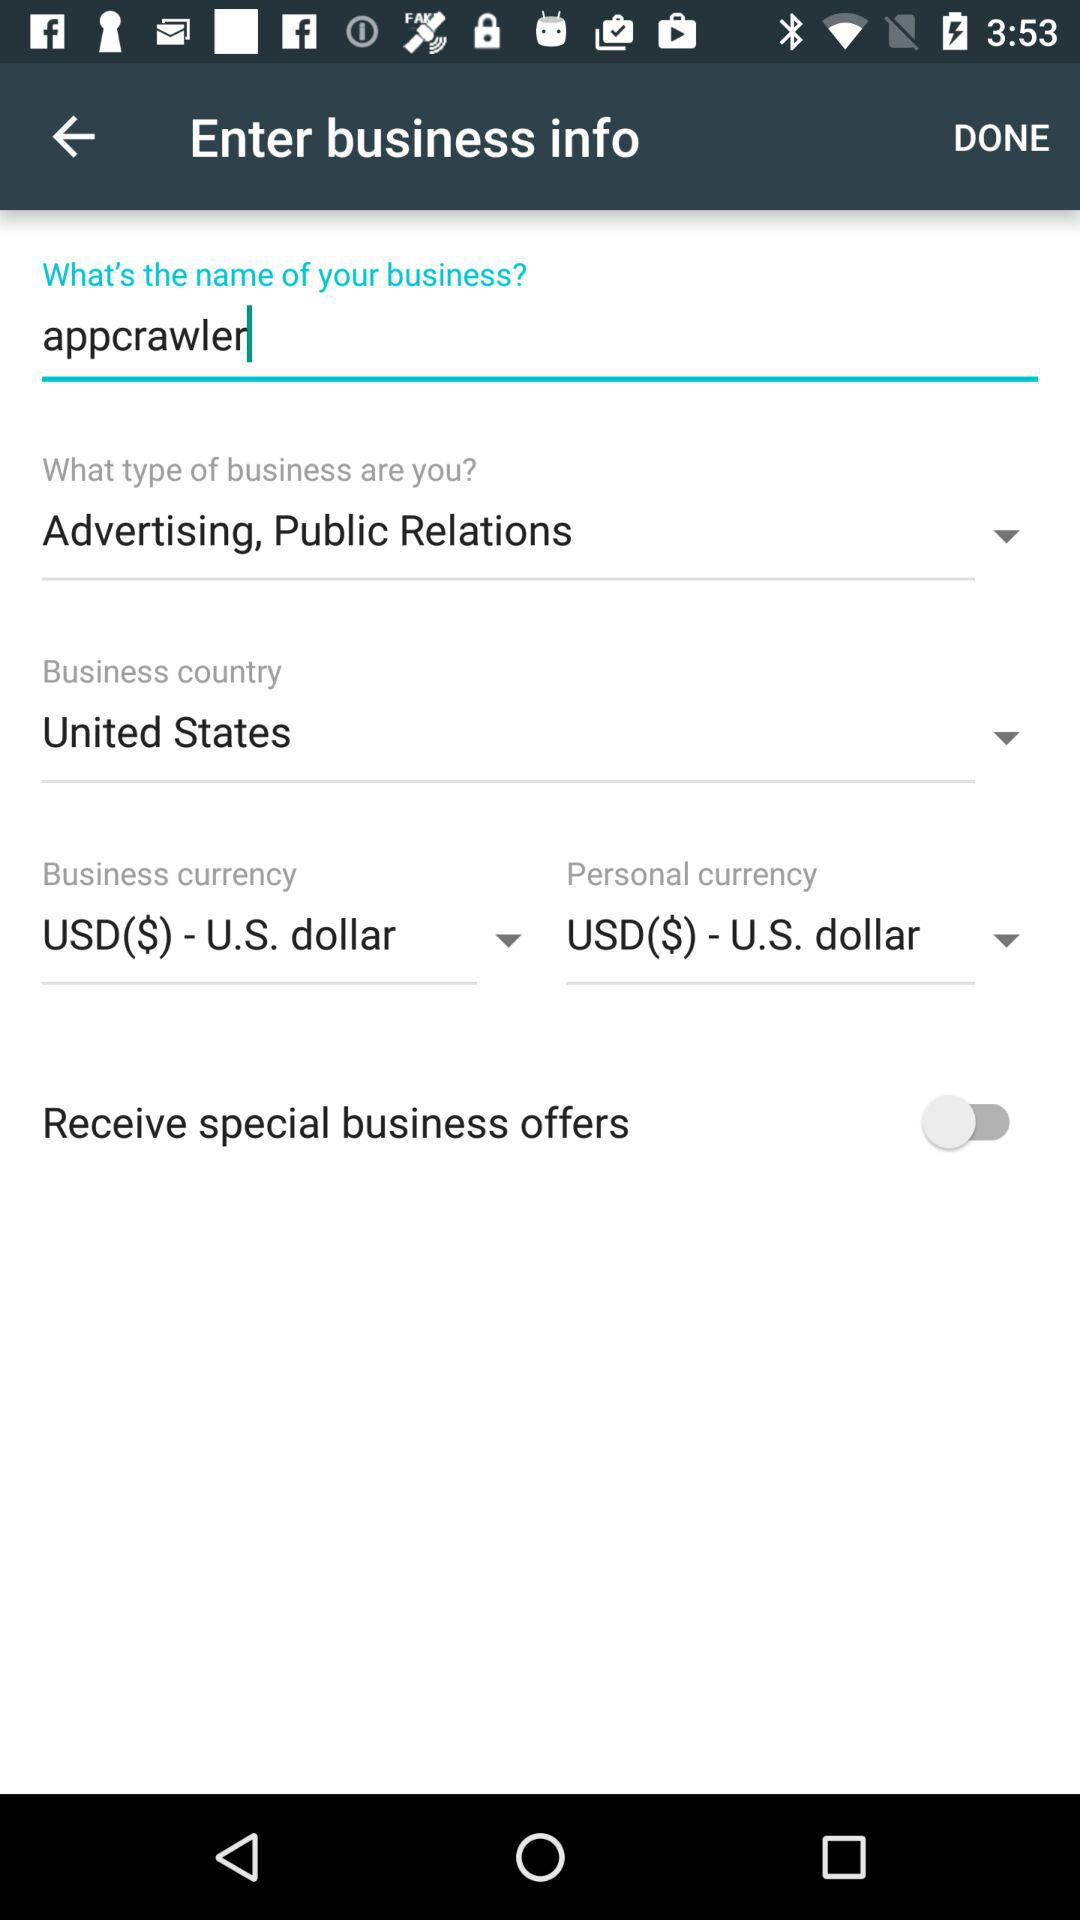What is the selected business type? The selected business type is "Advertising, Public Relations". 